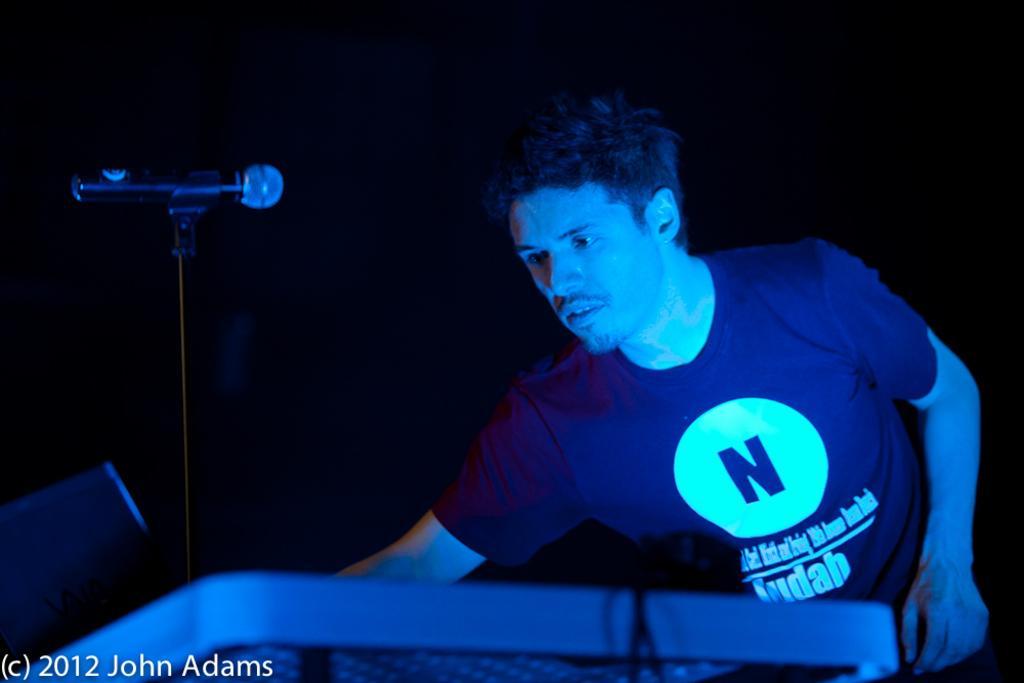Could you give a brief overview of what you see in this image? In this picture in the front there is a table and on the table there is a mic. Behind the table there is a man standing. 